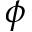Convert formula to latex. <formula><loc_0><loc_0><loc_500><loc_500>\phi</formula> 